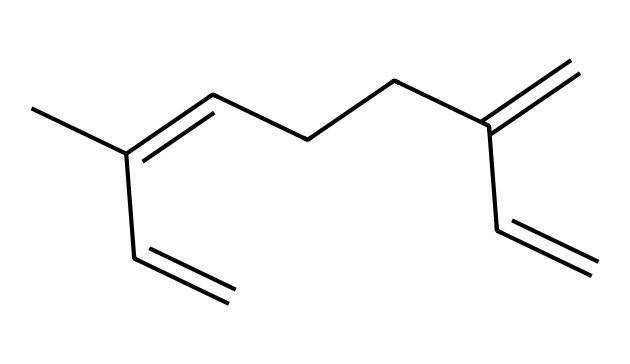What is the molecular formula of myrcene? To determine the molecular formula, we count the number of carbon (C), hydrogen (H), and any other atoms in the SMILES representation. There are 10 carbon atoms and 16 hydrogen atoms, leading to the formula C10H16.
Answer: C10H16 How many double bonds are present in myrcene? By examining the SMILES representation, we see there are three occurrences of "=" which indicates double bonds, thus there are three double bonds in total.
Answer: 3 What type of compound is myrcene classified as? Myrcene is a type of terpene, which is identified by its structure containing multiple double bonds and being derived from plant sources, particularly notable in hops and beer.
Answer: terpene What is the significance of myrcene in hops and beer? Myrcene contributes to the aroma and flavor of hops, making it significant in imparting a hoppy characteristic to the beer.
Answer: aroma and flavor Can myrcene be considered a cyclic compound? Evaluating the structure from the SMILES shows that myrcene does not have a ring structure but is instead a linear compound with an open chain, hence it cannot be classified as cyclic.
Answer: no How does the arrangement of double bonds affect the reactivity of myrcene? The position and number of double bonds increase the reactivity of myrcene, particularly making it more likely to participate in addition reactions due to the presence of those unsaturated bonds.
Answer: increases reactivity 